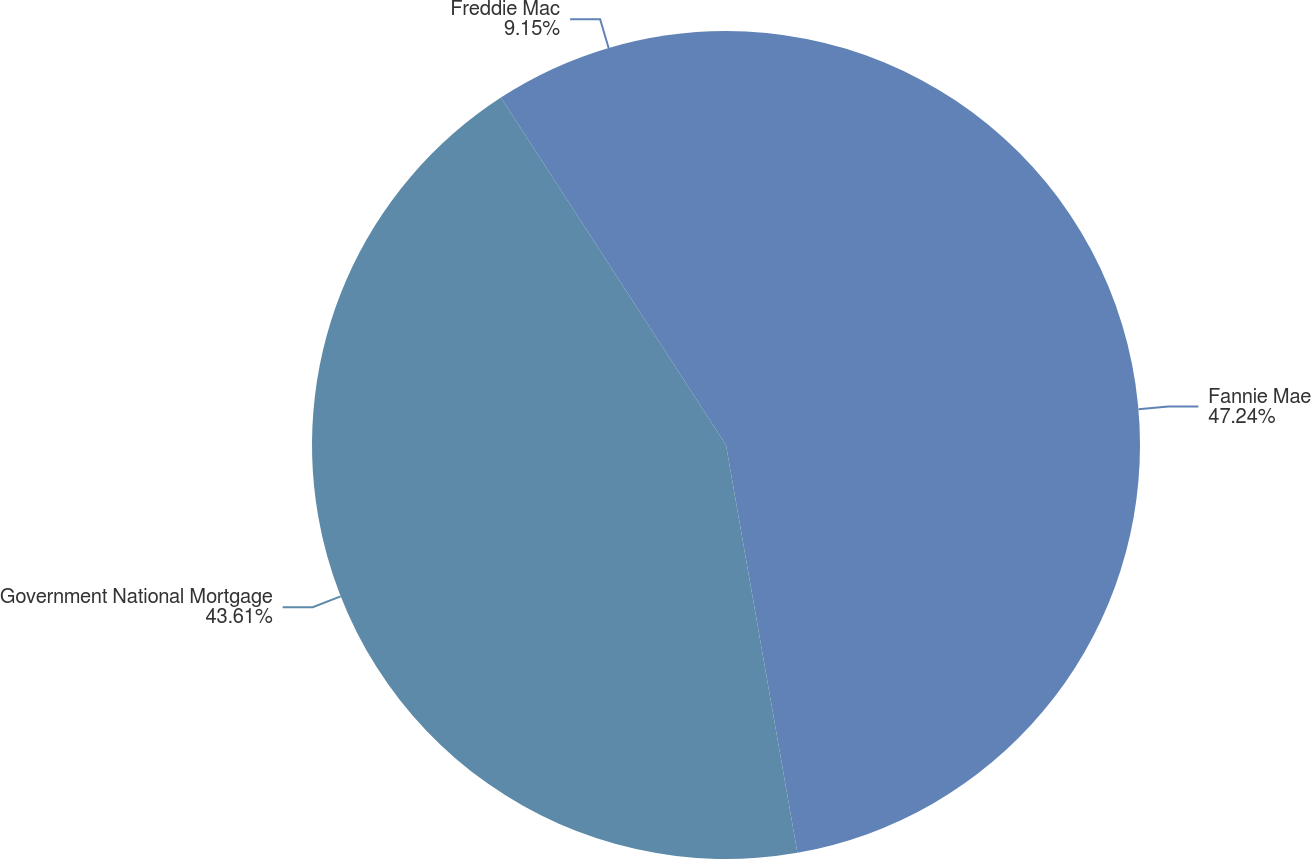Convert chart. <chart><loc_0><loc_0><loc_500><loc_500><pie_chart><fcel>Fannie Mae<fcel>Government National Mortgage<fcel>Freddie Mac<nl><fcel>47.24%<fcel>43.61%<fcel>9.15%<nl></chart> 